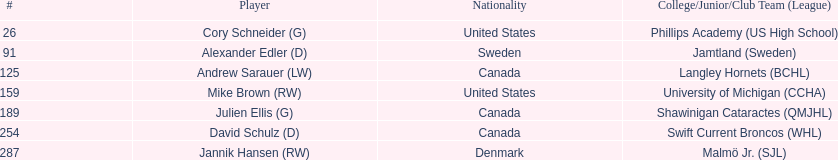Enumerate all players selected from canada in the draft. Andrew Sarauer (LW), Julien Ellis (G), David Schulz (D). 